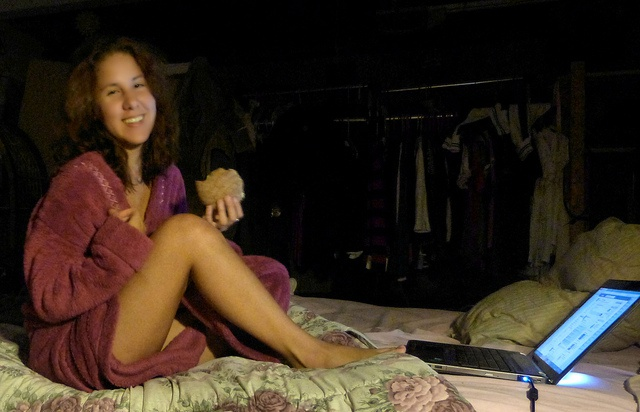Describe the objects in this image and their specific colors. I can see people in black, maroon, olive, and tan tones, bed in black, olive, gray, and tan tones, bed in black, tan, and gray tones, and laptop in black, lightblue, and gray tones in this image. 